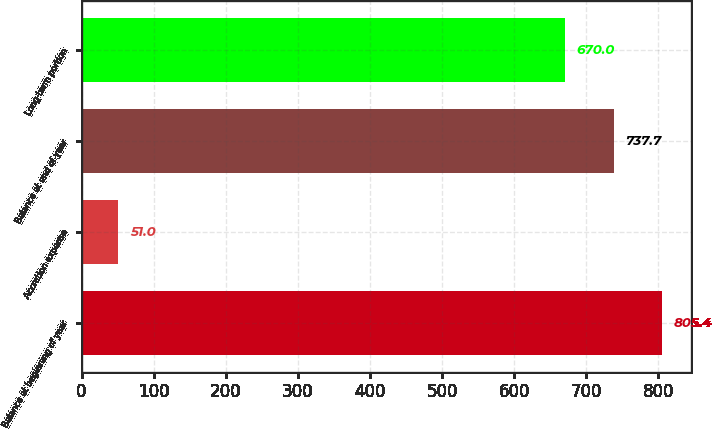Convert chart. <chart><loc_0><loc_0><loc_500><loc_500><bar_chart><fcel>Balance at beginning of year<fcel>Accretion expense<fcel>Balance at end of year<fcel>Long-term portion<nl><fcel>805.4<fcel>51<fcel>737.7<fcel>670<nl></chart> 